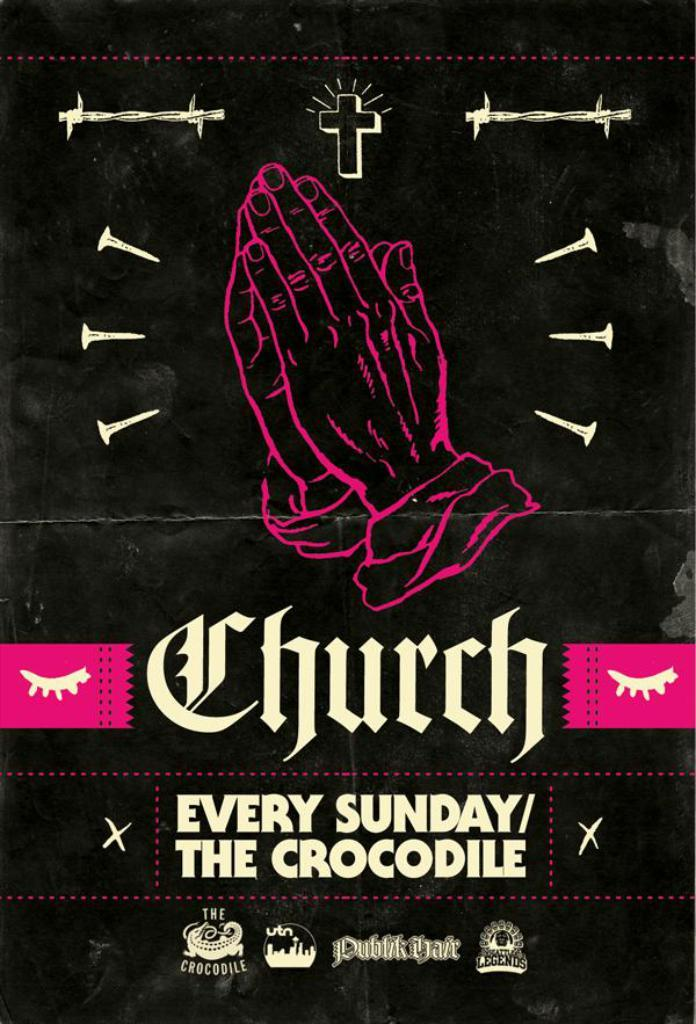<image>
Describe the image concisely. A flyer advertises Church on Sundays at an establishment called The Crocodile. 